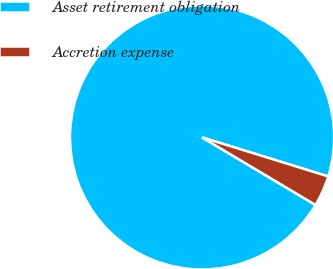<chart> <loc_0><loc_0><loc_500><loc_500><pie_chart><fcel>Asset retirement obligation<fcel>Accretion expense<nl><fcel>96.22%<fcel>3.78%<nl></chart> 